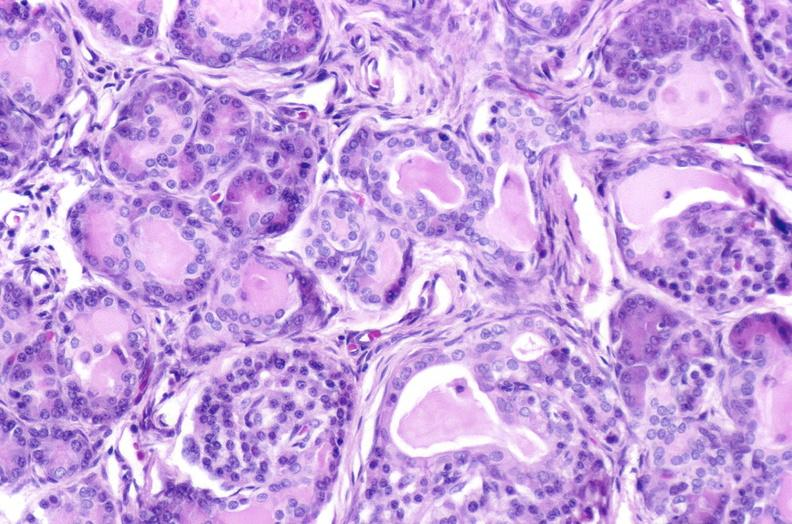what is present?
Answer the question using a single word or phrase. Pancreas 